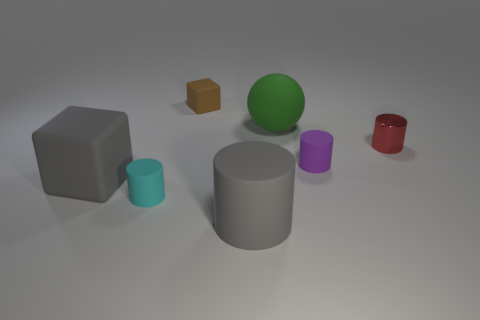Are there more big matte cubes than big cyan rubber cubes? Upon reviewing the image, it appears that there is only one big matte cube and no big cyan rubber cubes, so indeed, there are more big matte cubes than big cyan rubber cubes. 